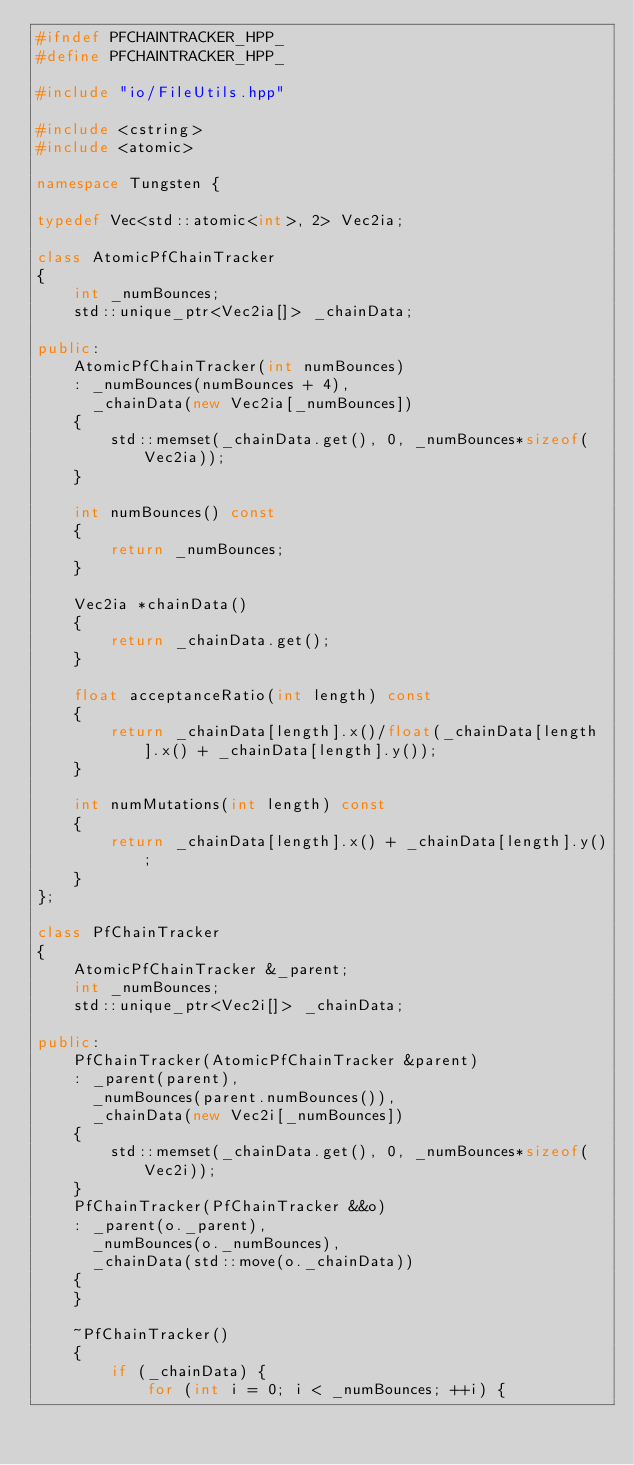Convert code to text. <code><loc_0><loc_0><loc_500><loc_500><_C++_>#ifndef PFCHAINTRACKER_HPP_
#define PFCHAINTRACKER_HPP_

#include "io/FileUtils.hpp"

#include <cstring>
#include <atomic>

namespace Tungsten {

typedef Vec<std::atomic<int>, 2> Vec2ia;

class AtomicPfChainTracker
{
    int _numBounces;
    std::unique_ptr<Vec2ia[]> _chainData;

public:
    AtomicPfChainTracker(int numBounces)
    : _numBounces(numBounces + 4),
      _chainData(new Vec2ia[_numBounces])
    {
        std::memset(_chainData.get(), 0, _numBounces*sizeof(Vec2ia));
    }

    int numBounces() const
    {
        return _numBounces;
    }

    Vec2ia *chainData()
    {
        return _chainData.get();
    }

    float acceptanceRatio(int length) const
    {
        return _chainData[length].x()/float(_chainData[length].x() + _chainData[length].y());
    }

    int numMutations(int length) const
    {
        return _chainData[length].x() + _chainData[length].y();
    }
};

class PfChainTracker
{
    AtomicPfChainTracker &_parent;
    int _numBounces;
    std::unique_ptr<Vec2i[]> _chainData;

public:
    PfChainTracker(AtomicPfChainTracker &parent)
    : _parent(parent),
      _numBounces(parent.numBounces()),
      _chainData(new Vec2i[_numBounces])
    {
        std::memset(_chainData.get(), 0, _numBounces*sizeof(Vec2i));
    }
    PfChainTracker(PfChainTracker &&o)
    : _parent(o._parent),
      _numBounces(o._numBounces),
      _chainData(std::move(o._chainData))
    {
    }

    ~PfChainTracker()
    {
        if (_chainData) {
            for (int i = 0; i < _numBounces; ++i) {</code> 